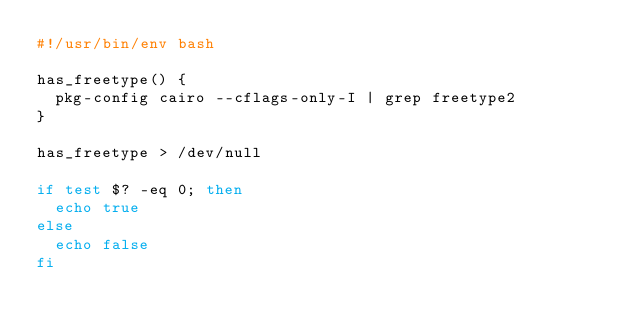Convert code to text. <code><loc_0><loc_0><loc_500><loc_500><_Bash_>#!/usr/bin/env bash

has_freetype() {
  pkg-config cairo --cflags-only-I | grep freetype2
}

has_freetype > /dev/null

if test $? -eq 0; then
  echo true
else
  echo false
fi
</code> 